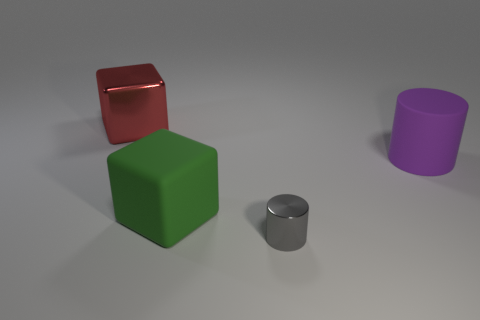Is there anything else that has the same size as the gray metallic thing?
Provide a succinct answer. No. There is a big green object; how many big metallic things are to the right of it?
Ensure brevity in your answer.  0. Are there an equal number of red metal blocks in front of the big purple cylinder and large green blocks?
Your answer should be very brief. No. How many objects are either blue balls or large purple things?
Your answer should be compact. 1. The large matte object that is in front of the large matte cylinder on the right side of the large green matte object is what shape?
Ensure brevity in your answer.  Cube. There is a thing that is made of the same material as the large green cube; what is its shape?
Provide a succinct answer. Cylinder. There is a metal object that is to the right of the matte thing that is on the left side of the large cylinder; what size is it?
Keep it short and to the point. Small. What is the shape of the large red metal object?
Provide a short and direct response. Cube. What number of large things are either green rubber objects or blue matte blocks?
Give a very brief answer. 1. There is a shiny object that is the same shape as the large green rubber object; what size is it?
Your answer should be compact. Large. 